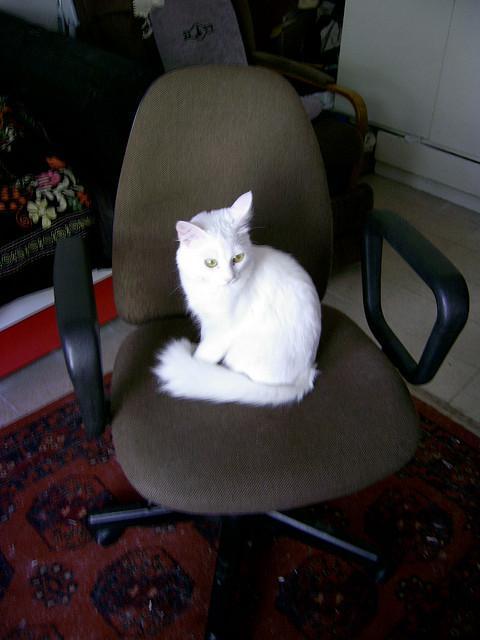How many people are wearing glasses?
Give a very brief answer. 0. 